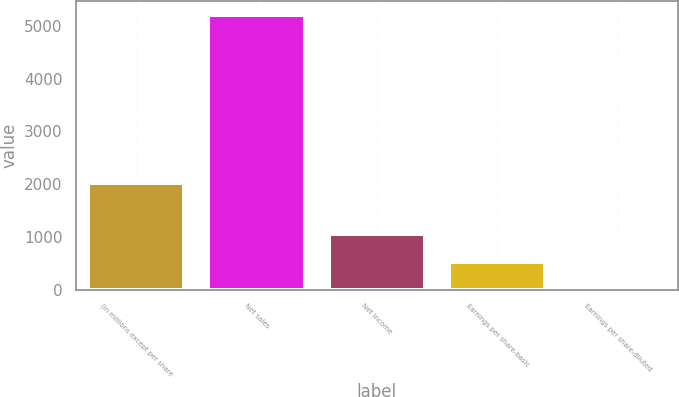<chart> <loc_0><loc_0><loc_500><loc_500><bar_chart><fcel>(in millions except per share<fcel>Net sales<fcel>Net income<fcel>Earnings per share-basic<fcel>Earnings per share-diluted<nl><fcel>2017<fcel>5209<fcel>1045.12<fcel>524.63<fcel>4.14<nl></chart> 